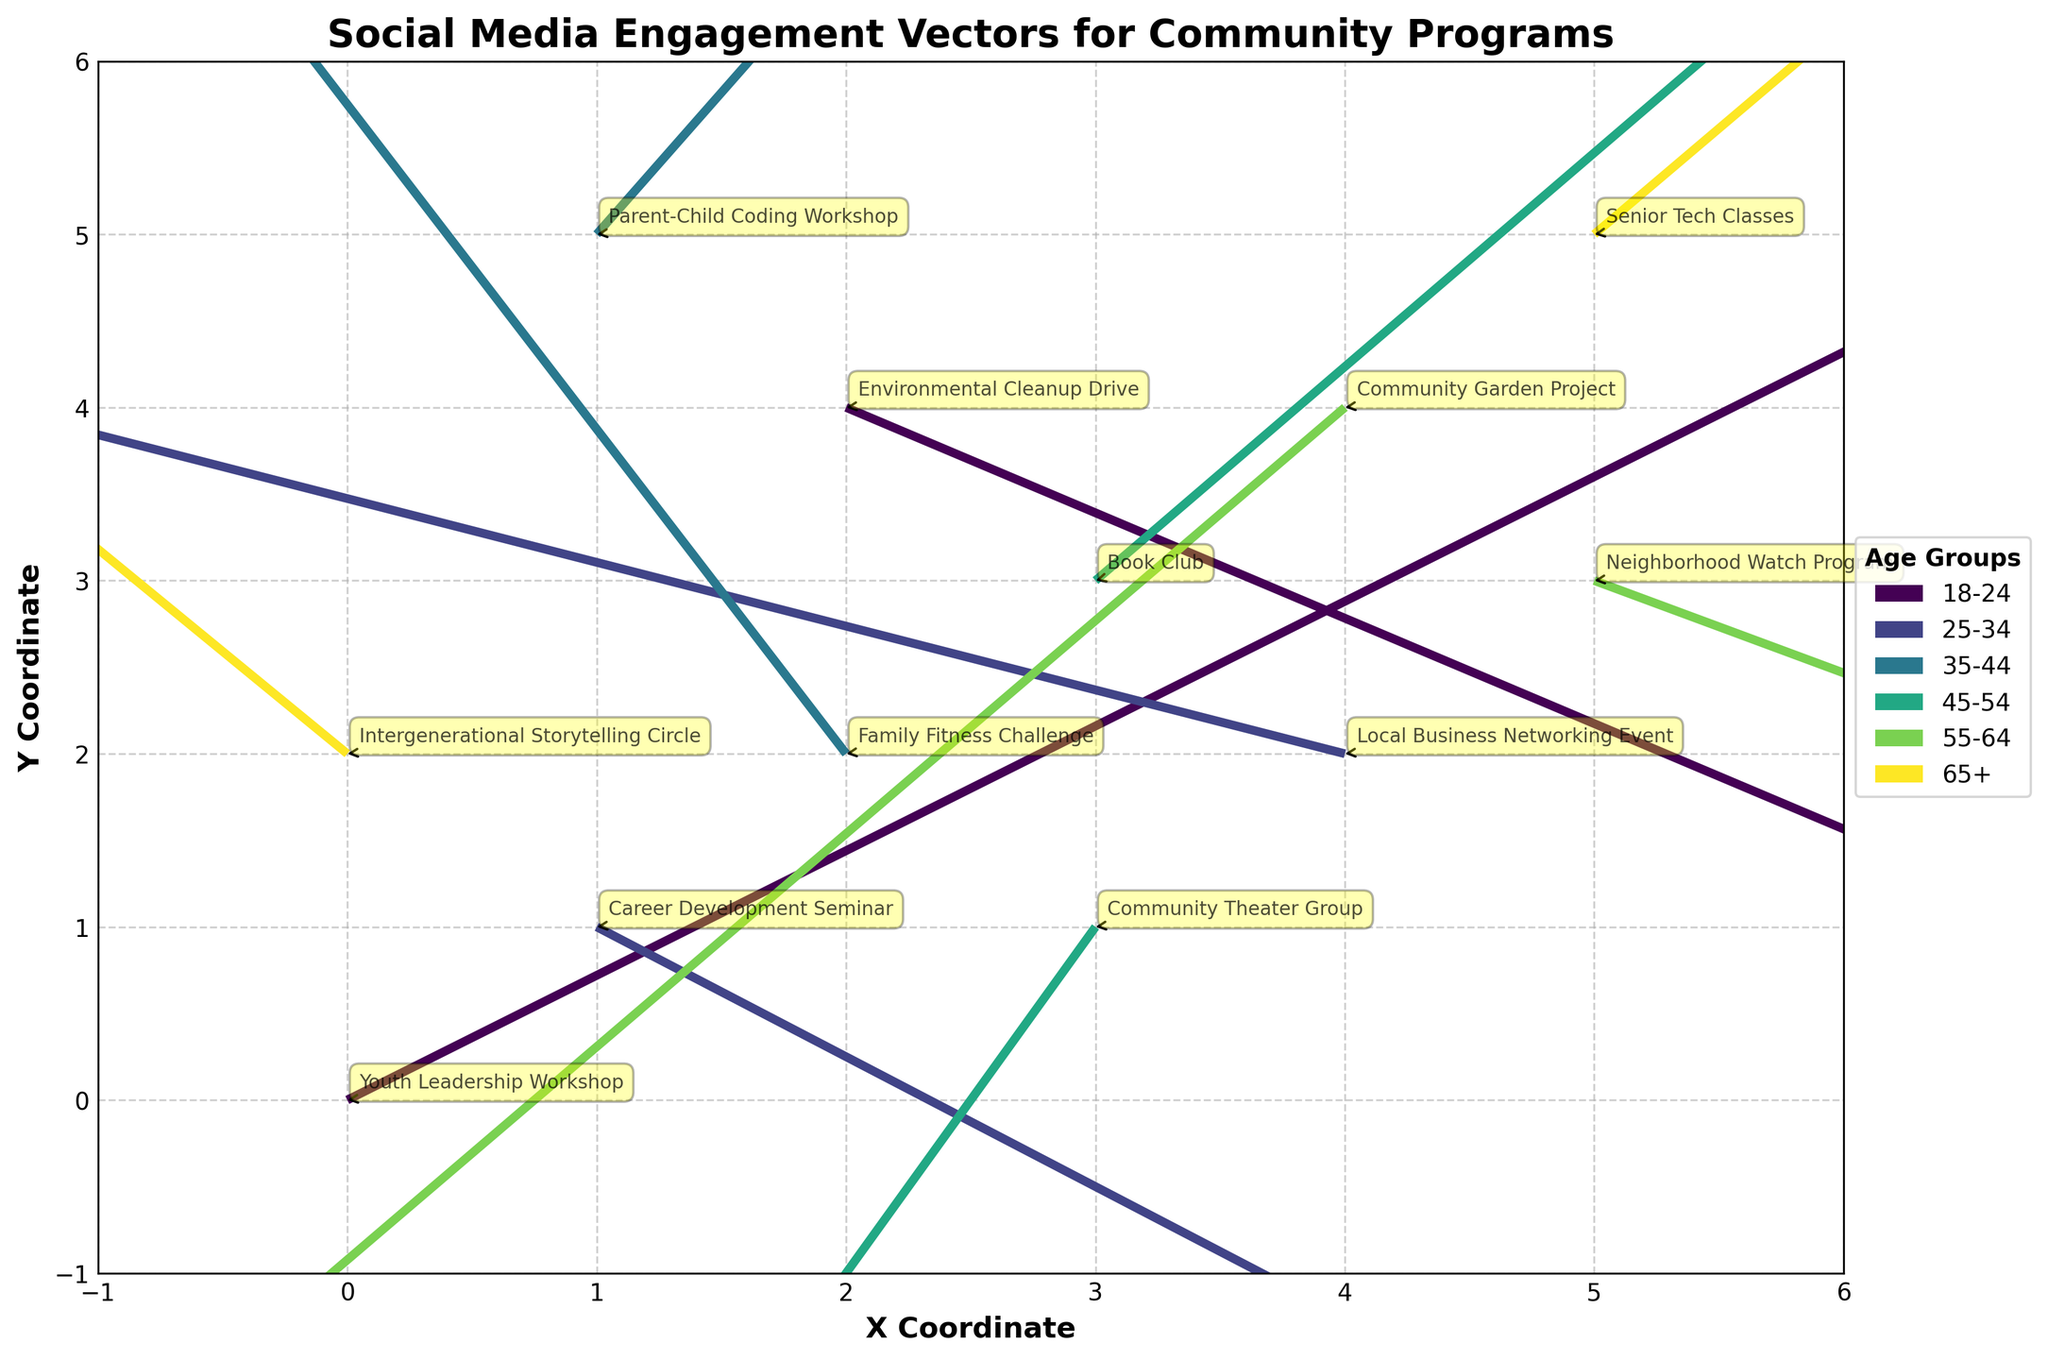What's the title of the figure? The title is written at the top of the figure, usually in a larger and bolder font. It helps in summarizing the data presented.
Answer: Social Media Engagement Vectors for Community Programs What are the labels on the X and Y axes? The labels are usually located next to the axes and indicate what the axes represent. The X-axis is labeled 'X Coordinate' and the Y-axis is labeled 'Y Coordinate'.
Answer: X Coordinate, Y Coordinate How many different age groups are represented in the figure? Each age group is represented by a different color in the figure. The legend on the right side of the plot shows all the age groups. By counting the unique colors or entries in the legend, we can determine the number of age groups.
Answer: 6 Which community program has the highest horizontal engagement vector (u value)? The community program with the highest horizontal engagement vector is determined by comparing the u values for all programs. The highest u value is 2.5 for the 'Youth Leadership Workshop'.
Answer: Youth Leadership Workshop Which age group has the most significant vector pointing downward? A vector pointing downward indicates a negative v value. The longest downward vector can be identified by finding the minimum v value among the age groups. The 'Community Garden Project' in the 55-64 age group has the most significant downward vector with a v value of -1.6.
Answer: 55-64 How many community programs have vectors pointing both rightward and upward? Vectors pointing both rightward and upward will have positive u and v values. By examining the plot, we identify the program names associated with positive u and v values. The programs 'Youth Leadership Workshop', 'Book Club', 'Parent-Child Coding Workshop', and 'Senior Tech Classes' fit this criterion.
Answer: 4 Which program from the 35-44 age group has the largest magnitude vector? The magnitude of a vector is calculated using the formula √(u² + v²). For the two programs in the 35-44 age group, 'Family Fitness Challenge' has u = -0.8 and v = 1.5, so √((-0.8)² + (1.5)²) = √2.89 ≈ 1.70, and 'Parent-Child Coding Workshop' has u = 1.1 and v = 1.8, so √((1.1)² + (1.8)²) = √4.25 ≈ 2.06. 'Parent-Child Coding Workshop' has the larger magnitude vector.
Answer: Parent-Child Coding Workshop Which age group has the vector according to the program that moved the most leftward? The vector moving most leftward will have the most negative u value. Upon inspecting the u values, the 'Local Business Networking Event' in the 25-34 age group with u = -1.9 is the most leftward vector.
Answer: 25-34 Which program from the 45-54 age group has the vector pointing most downward? The vector pointing most downward will have the most negative v value. For the two programs in the 45-54 age group, we compare v values. The 'Community Theater Group' has a v value of -1.2, which is more negative than 'Book Club's' v value of 2.1.
Answer: Community Theater Group 